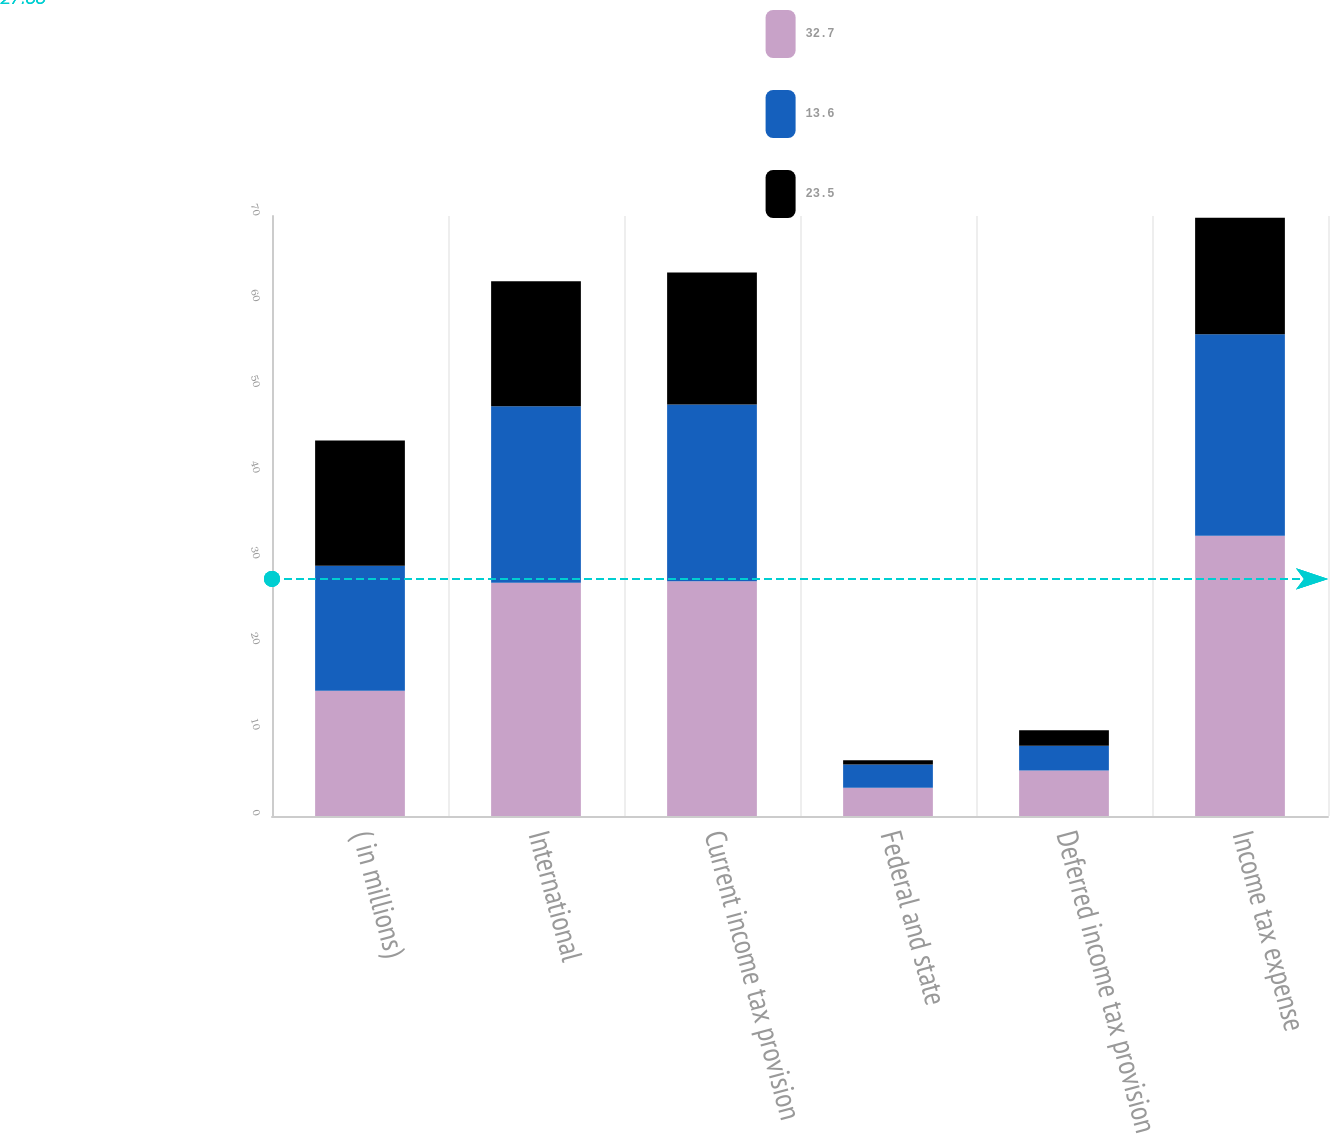Convert chart. <chart><loc_0><loc_0><loc_500><loc_500><stacked_bar_chart><ecel><fcel>( in millions)<fcel>International<fcel>Current income tax provision<fcel>Federal and state<fcel>Deferred income tax provision<fcel>Income tax expense<nl><fcel>32.7<fcel>14.6<fcel>27.2<fcel>27.4<fcel>3.3<fcel>5.3<fcel>32.7<nl><fcel>13.6<fcel>14.6<fcel>20.6<fcel>20.6<fcel>2.7<fcel>2.9<fcel>23.5<nl><fcel>23.5<fcel>14.6<fcel>14.6<fcel>15.4<fcel>0.5<fcel>1.8<fcel>13.6<nl></chart> 